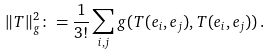Convert formula to latex. <formula><loc_0><loc_0><loc_500><loc_500>\| T \| ^ { 2 } _ { g } \colon = \frac { 1 } { 3 ! } \sum _ { i , j } g ( T ( e _ { i } , e _ { j } ) , T ( e _ { i } , e _ { j } ) ) \, .</formula> 